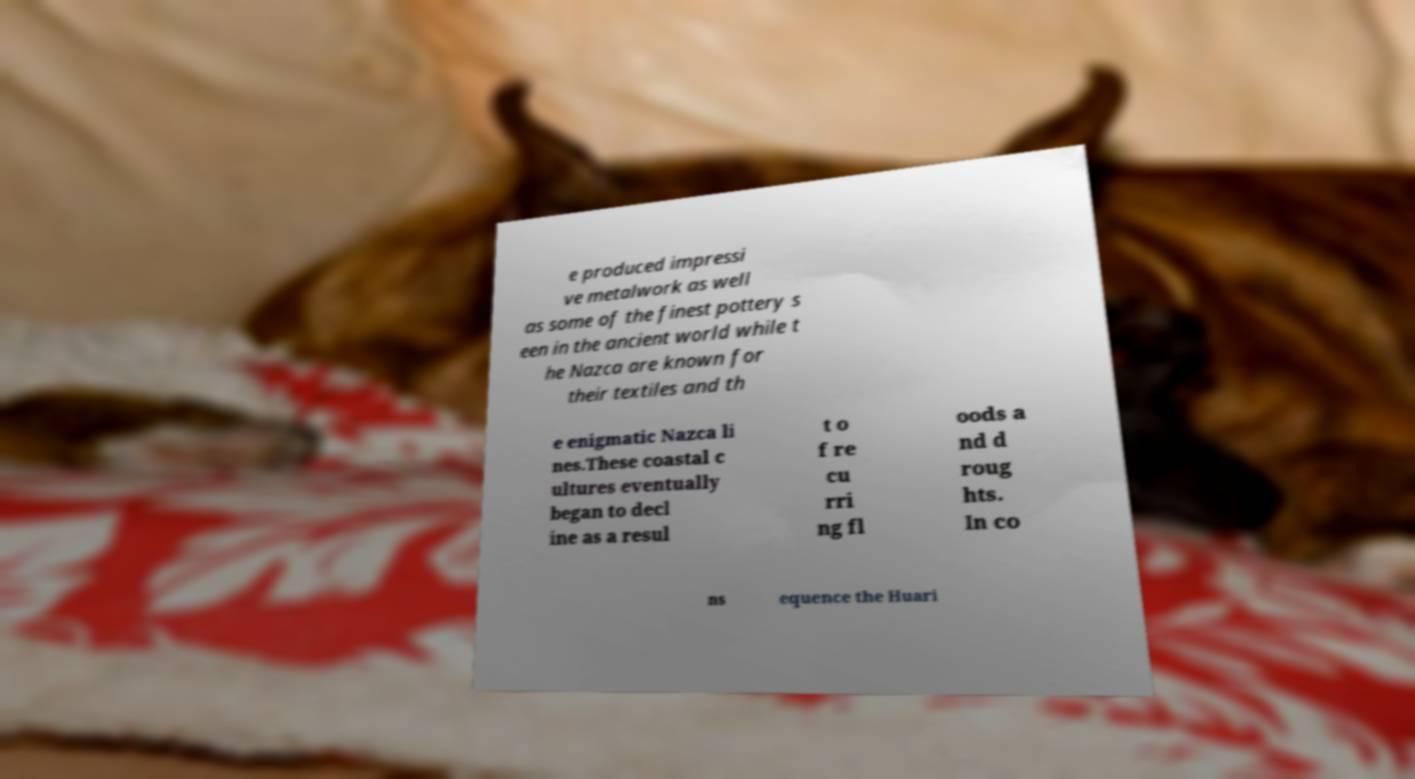What messages or text are displayed in this image? I need them in a readable, typed format. e produced impressi ve metalwork as well as some of the finest pottery s een in the ancient world while t he Nazca are known for their textiles and th e enigmatic Nazca li nes.These coastal c ultures eventually began to decl ine as a resul t o f re cu rri ng fl oods a nd d roug hts. In co ns equence the Huari 